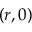Convert formula to latex. <formula><loc_0><loc_0><loc_500><loc_500>( r , 0 )</formula> 